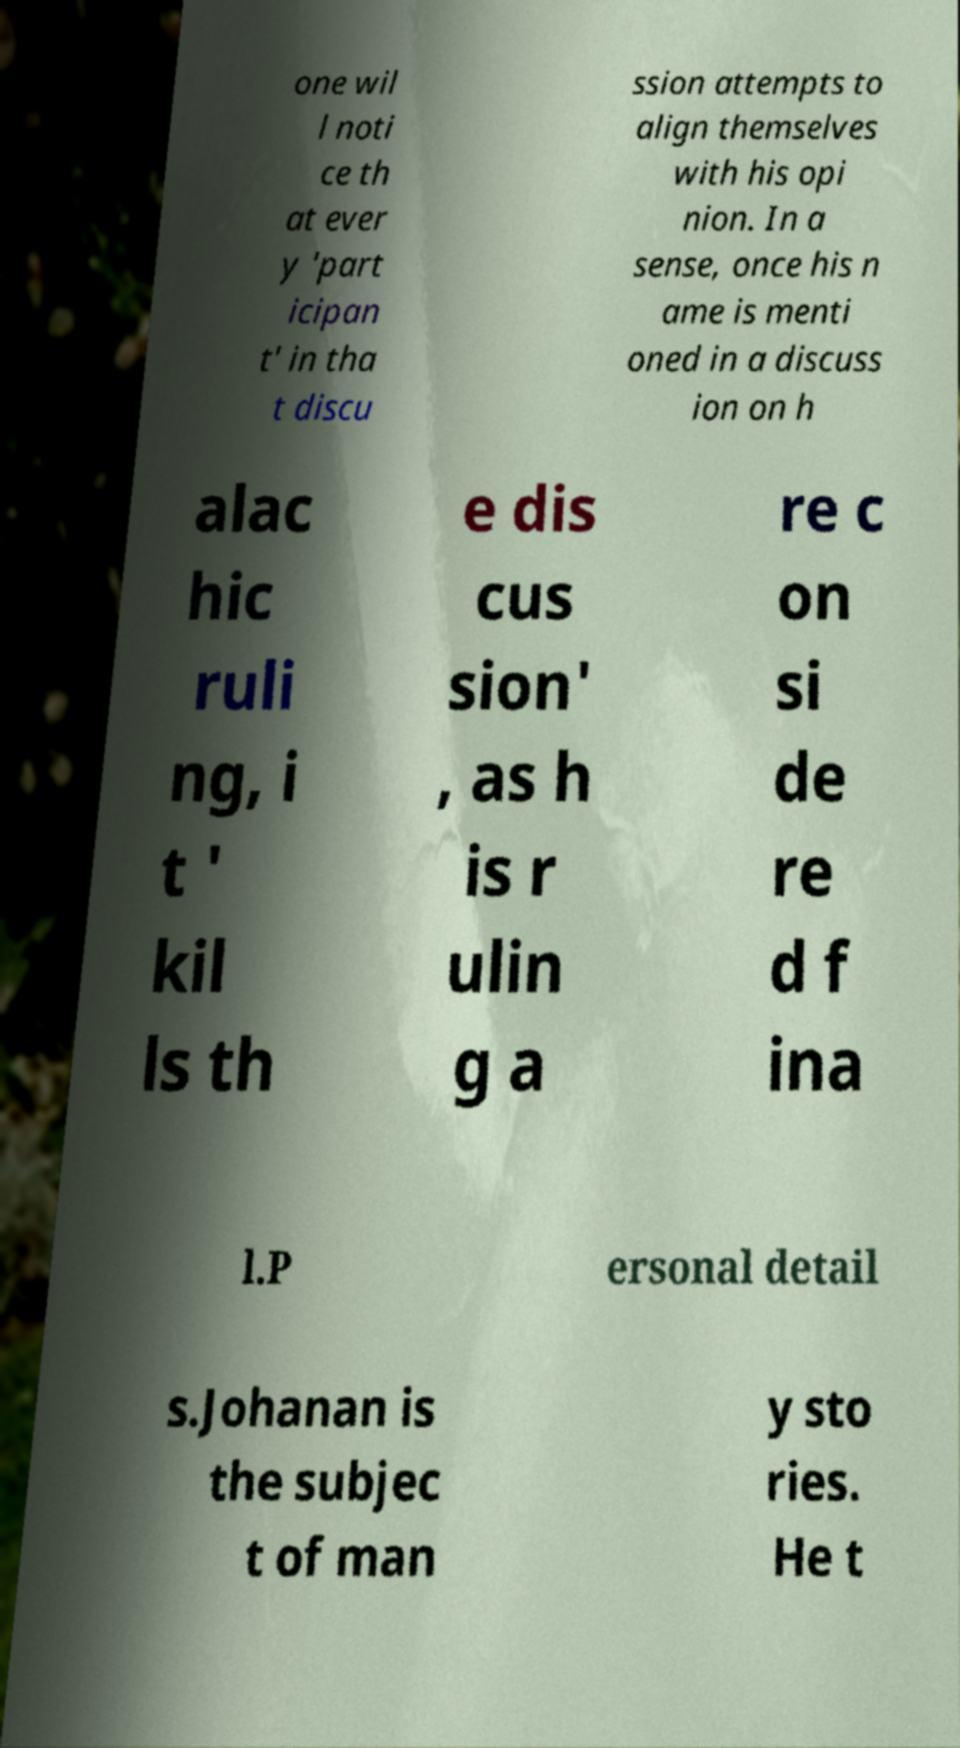Can you accurately transcribe the text from the provided image for me? one wil l noti ce th at ever y 'part icipan t' in tha t discu ssion attempts to align themselves with his opi nion. In a sense, once his n ame is menti oned in a discuss ion on h alac hic ruli ng, i t ' kil ls th e dis cus sion' , as h is r ulin g a re c on si de re d f ina l.P ersonal detail s.Johanan is the subjec t of man y sto ries. He t 